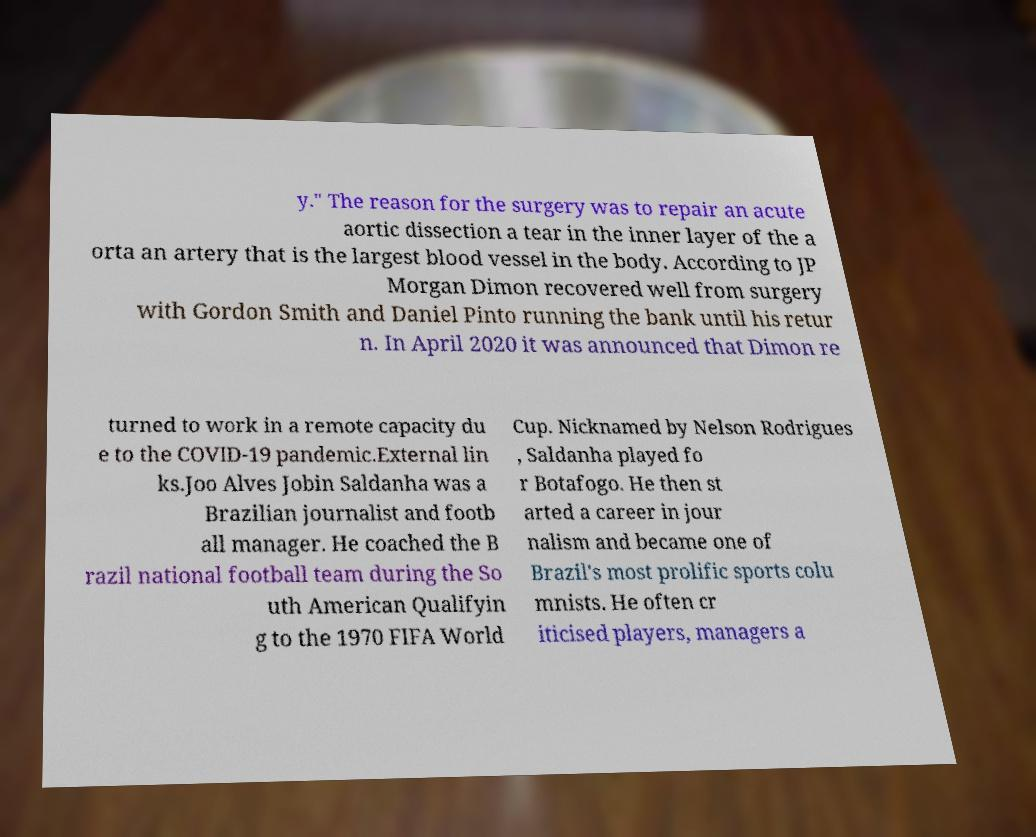I need the written content from this picture converted into text. Can you do that? y." The reason for the surgery was to repair an acute aortic dissection a tear in the inner layer of the a orta an artery that is the largest blood vessel in the body. According to JP Morgan Dimon recovered well from surgery with Gordon Smith and Daniel Pinto running the bank until his retur n. In April 2020 it was announced that Dimon re turned to work in a remote capacity du e to the COVID-19 pandemic.External lin ks.Joo Alves Jobin Saldanha was a Brazilian journalist and footb all manager. He coached the B razil national football team during the So uth American Qualifyin g to the 1970 FIFA World Cup. Nicknamed by Nelson Rodrigues , Saldanha played fo r Botafogo. He then st arted a career in jour nalism and became one of Brazil's most prolific sports colu mnists. He often cr iticised players, managers a 